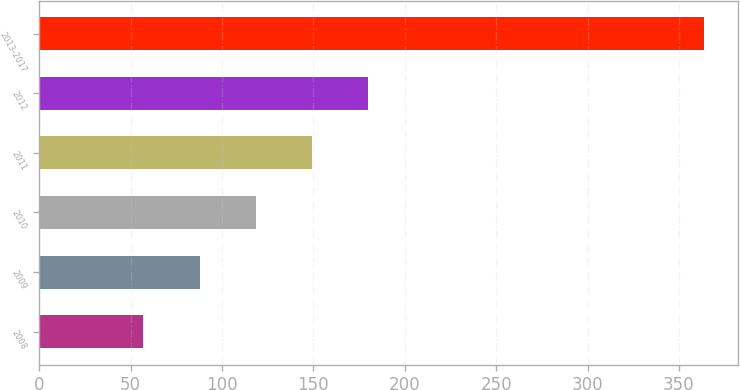Convert chart. <chart><loc_0><loc_0><loc_500><loc_500><bar_chart><fcel>2008<fcel>2009<fcel>2010<fcel>2011<fcel>2012<fcel>2013-2017<nl><fcel>57<fcel>87.7<fcel>118.4<fcel>149.1<fcel>179.8<fcel>364<nl></chart> 